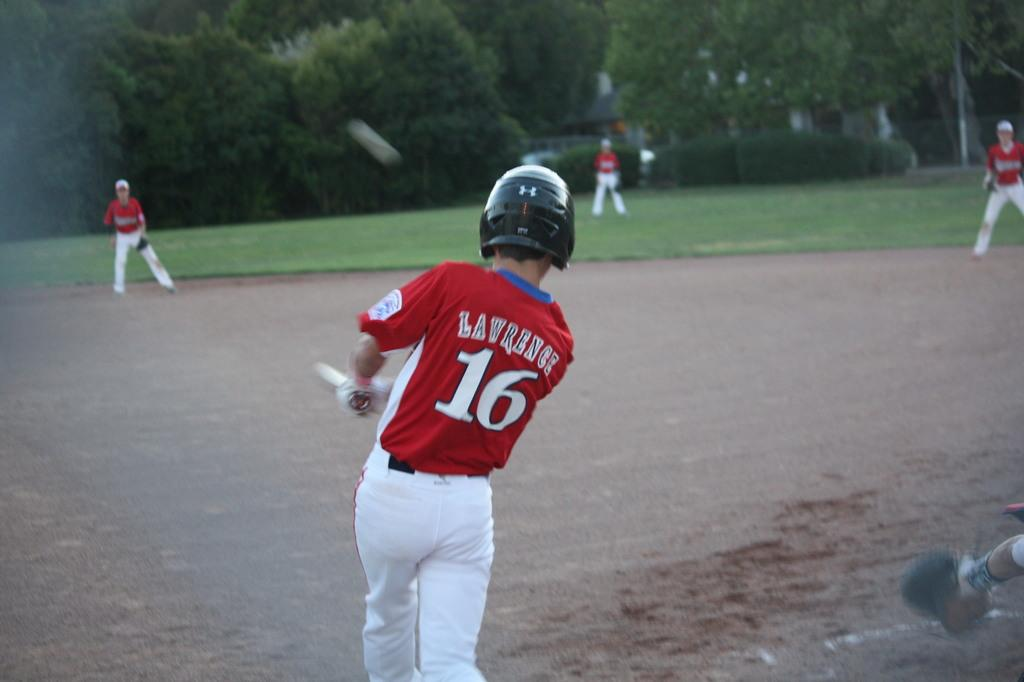<image>
Present a compact description of the photo's key features. Lawrence, wearing number 16 has, just swung at a pitch. 